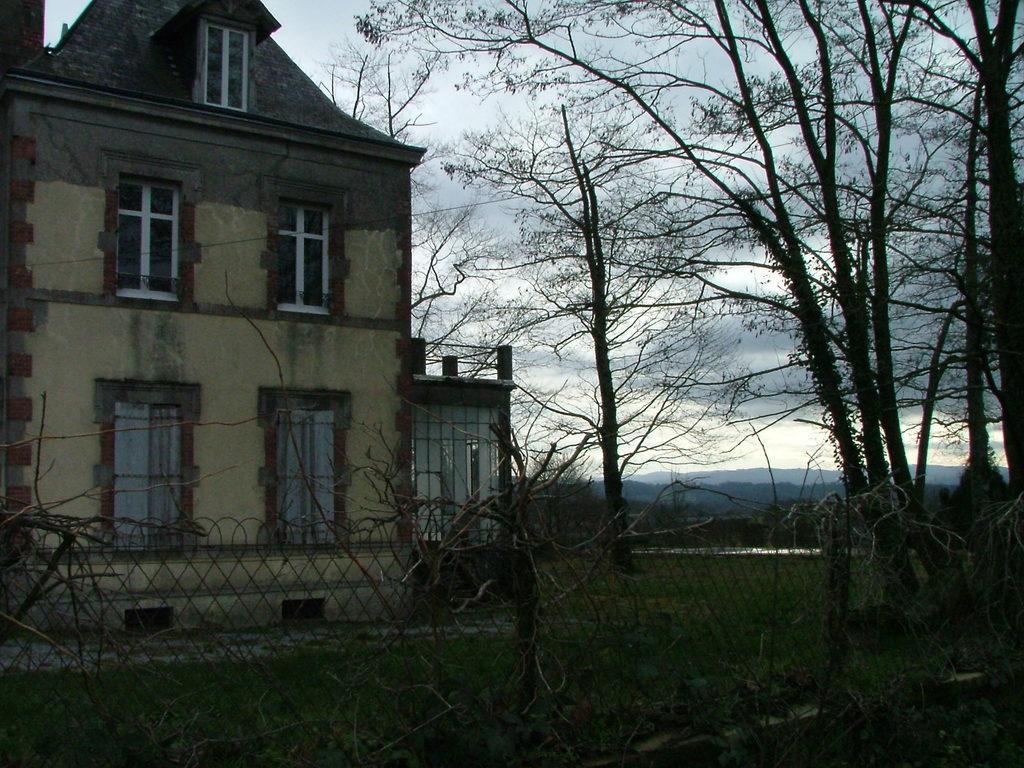What can be seen in the sky in the image? The sky with clouds is visible in the image. What type of vegetation is present in the image? There are trees in the image. What type of landscape feature is present in the image? Hills are present in the image. What type of structure is visible in the image? There is a building in the image. What is visible at the bottom of the image? The ground is visible in the image. What type of plant is present in the image? Creepers are present in the image. What type of barrier is visible in the image? A fence is visible in the image. How many rings are visible on the building in the image? There are no rings visible on the building in the image. What type of toys can be seen in the image? There are no toys present in the image. 